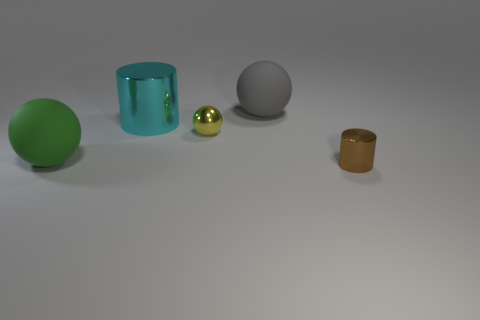Subtract all metal spheres. How many spheres are left? 2 Add 1 small purple matte cubes. How many objects exist? 6 Subtract all yellow spheres. How many spheres are left? 2 Subtract 0 gray cylinders. How many objects are left? 5 Subtract all balls. How many objects are left? 2 Subtract 1 spheres. How many spheres are left? 2 Subtract all gray cylinders. Subtract all gray blocks. How many cylinders are left? 2 Subtract all red cubes. How many brown balls are left? 0 Subtract all big cylinders. Subtract all green spheres. How many objects are left? 3 Add 4 gray rubber balls. How many gray rubber balls are left? 5 